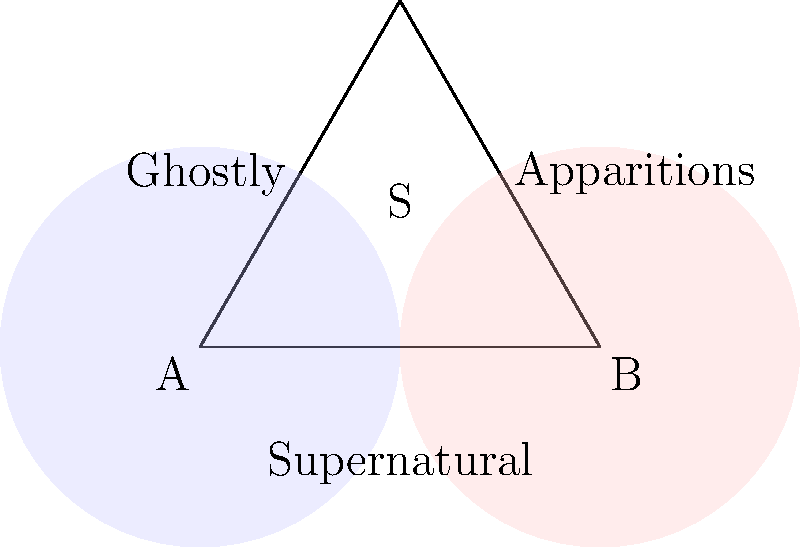In your shop, you've been tracking supernatural events. You've noticed that out of all supernatural occurrences, 60% involve ghostly sightings (A), 45% involve apparitions (B), and 25% involve both. If a supernatural event occurs, what is the probability that it involves either ghostly sightings or apparitions, but not both? Let's approach this step-by-step:

1) Let S be the set of all supernatural events.
2) A represents ghostly sightings, and B represents apparitions.

3) Given:
   P(A) = 60% = 0.60
   P(B) = 45% = 0.45
   P(A ∩ B) = 25% = 0.25

4) We need to find P(A ∪ B) - P(A ∩ B), which represents the probability of events in either A or B, but not both.

5) First, let's calculate P(A ∪ B) using the addition rule of probability:
   P(A ∪ B) = P(A) + P(B) - P(A ∩ B)
   P(A ∪ B) = 0.60 + 0.45 - 0.25 = 0.80

6) Now, we can calculate our desired probability:
   P((A ∪ B) - (A ∩ B)) = P(A ∪ B) - P(A ∩ B)
                        = 0.80 - 0.25
                        = 0.55

Therefore, the probability of a supernatural event involving either ghostly sightings or apparitions, but not both, is 0.55 or 55%.
Answer: 0.55 